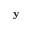<formula> <loc_0><loc_0><loc_500><loc_500>{ y }</formula> 